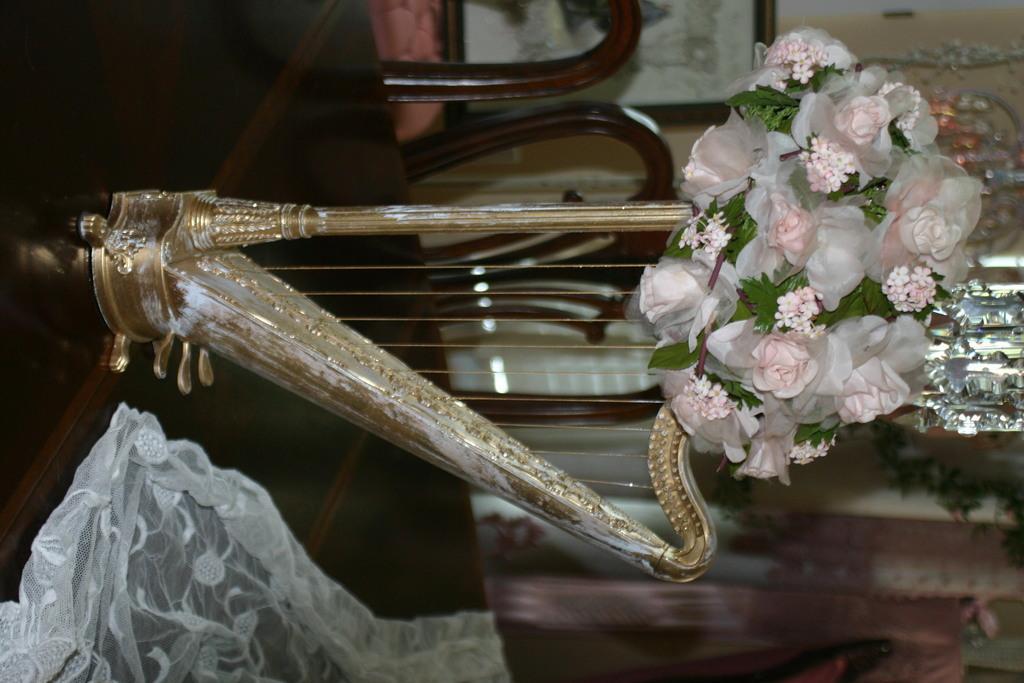Describe this image in one or two sentences. In the picture we can see a table on it, we can see a musical instrument with strings and beside it, we can see a cloth which is white in color and it is transparent and near the table we can see some chairs and in the background we can see a wall. 